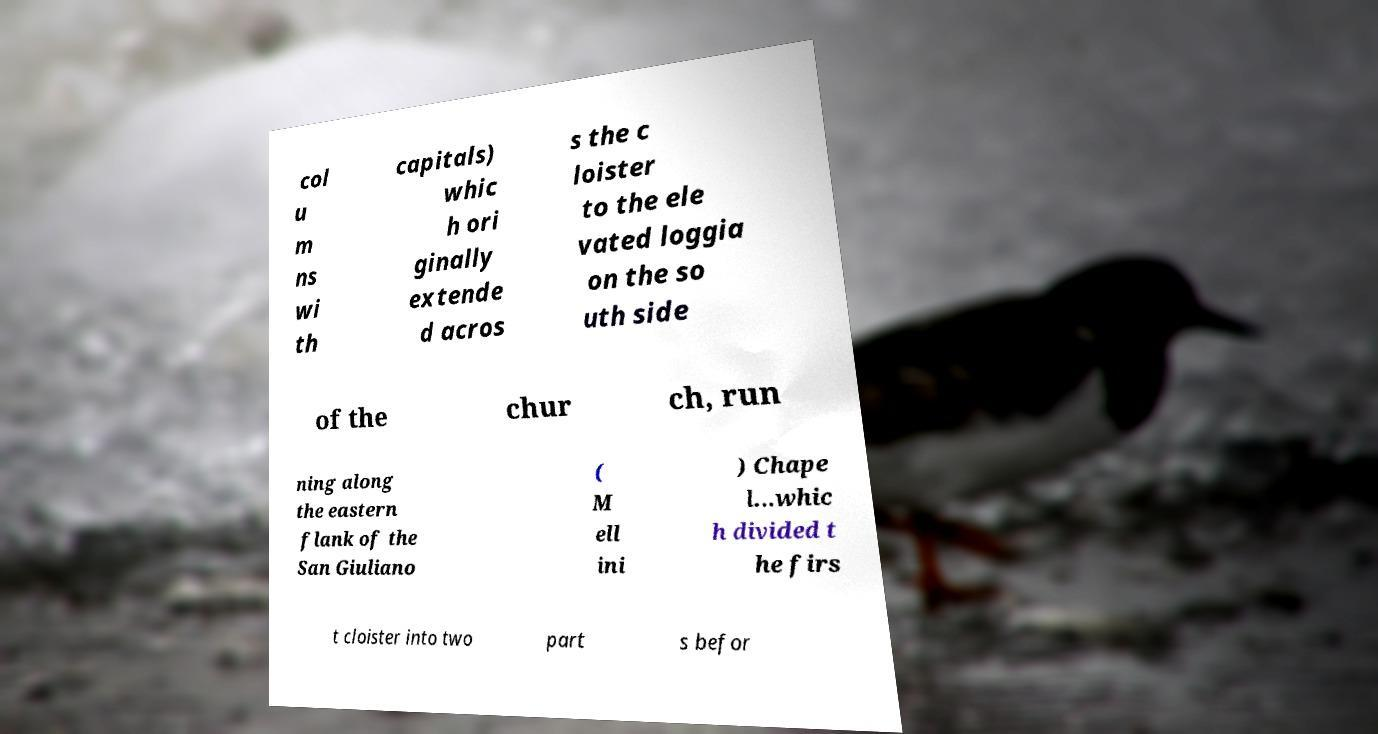Please read and relay the text visible in this image. What does it say? col u m ns wi th capitals) whic h ori ginally extende d acros s the c loister to the ele vated loggia on the so uth side of the chur ch, run ning along the eastern flank of the San Giuliano ( M ell ini ) Chape l...whic h divided t he firs t cloister into two part s befor 